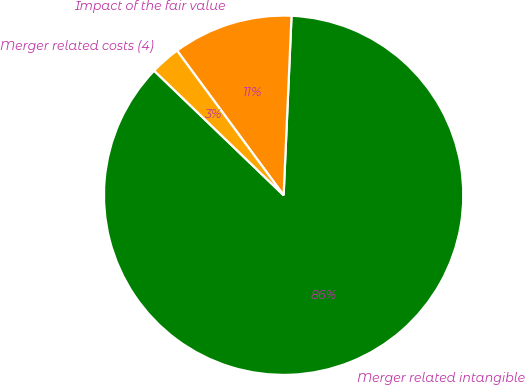<chart> <loc_0><loc_0><loc_500><loc_500><pie_chart><fcel>Merger related intangible<fcel>Impact of the fair value<fcel>Merger related costs (4)<nl><fcel>86.49%<fcel>10.81%<fcel>2.7%<nl></chart> 